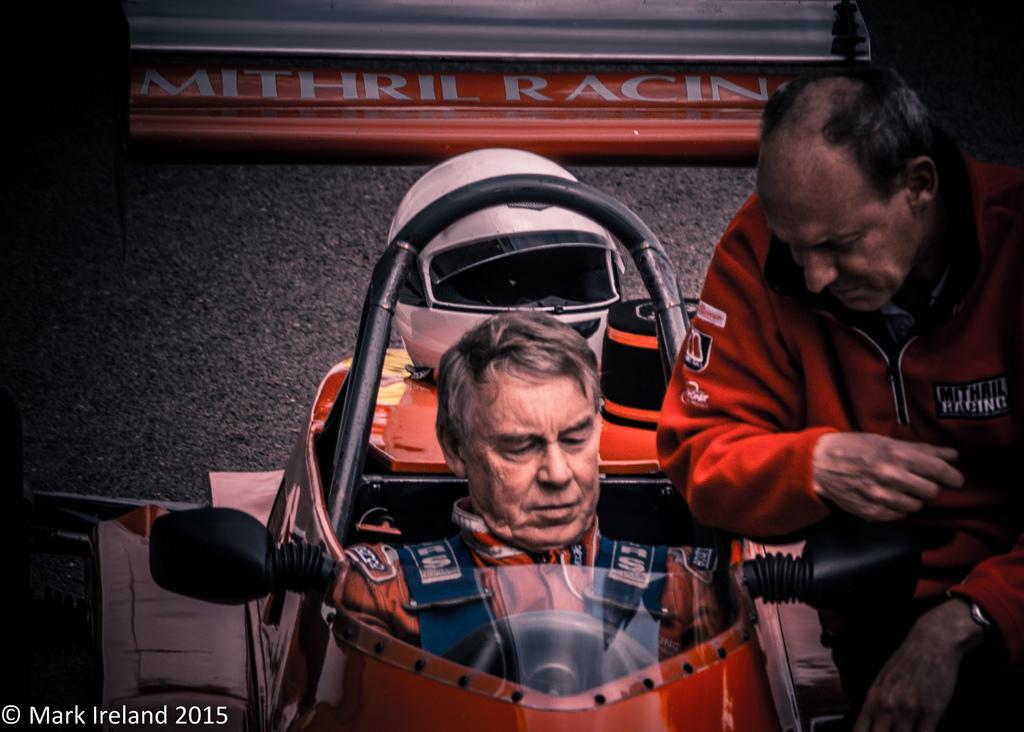In one or two sentences, can you explain what this image depicts? In the image we can see two men wearing clothes and the right side man is wearing wrist watch and the left side man is sitting on the racing car. Here we can see road and at the left bottom we can see water mark. 